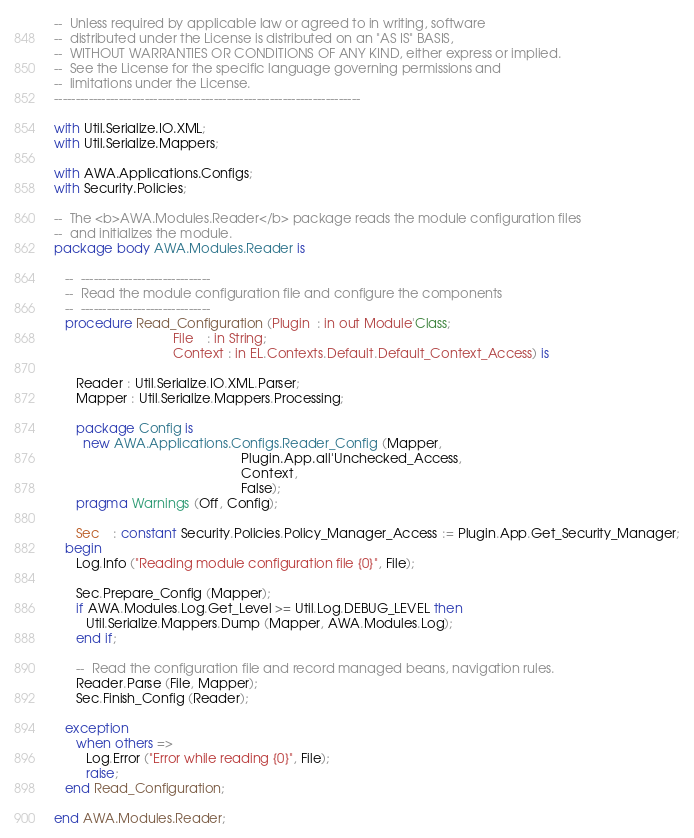<code> <loc_0><loc_0><loc_500><loc_500><_Ada_>--  Unless required by applicable law or agreed to in writing, software
--  distributed under the License is distributed on an "AS IS" BASIS,
--  WITHOUT WARRANTIES OR CONDITIONS OF ANY KIND, either express or implied.
--  See the License for the specific language governing permissions and
--  limitations under the License.
-----------------------------------------------------------------------

with Util.Serialize.IO.XML;
with Util.Serialize.Mappers;

with AWA.Applications.Configs;
with Security.Policies;

--  The <b>AWA.Modules.Reader</b> package reads the module configuration files
--  and initializes the module.
package body AWA.Modules.Reader is

   --  ------------------------------
   --  Read the module configuration file and configure the components
   --  ------------------------------
   procedure Read_Configuration (Plugin  : in out Module'Class;
                                 File    : in String;
                                 Context : in EL.Contexts.Default.Default_Context_Access) is

      Reader : Util.Serialize.IO.XML.Parser;
      Mapper : Util.Serialize.Mappers.Processing;

      package Config is
        new AWA.Applications.Configs.Reader_Config (Mapper,
                                                    Plugin.App.all'Unchecked_Access,
                                                    Context,
                                                    False);
      pragma Warnings (Off, Config);

      Sec    : constant Security.Policies.Policy_Manager_Access := Plugin.App.Get_Security_Manager;
   begin
      Log.Info ("Reading module configuration file {0}", File);

      Sec.Prepare_Config (Mapper);
      if AWA.Modules.Log.Get_Level >= Util.Log.DEBUG_LEVEL then
         Util.Serialize.Mappers.Dump (Mapper, AWA.Modules.Log);
      end if;

      --  Read the configuration file and record managed beans, navigation rules.
      Reader.Parse (File, Mapper);
      Sec.Finish_Config (Reader);

   exception
      when others =>
         Log.Error ("Error while reading {0}", File);
         raise;
   end Read_Configuration;

end AWA.Modules.Reader;
</code> 